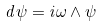<formula> <loc_0><loc_0><loc_500><loc_500>d \psi = i \omega \wedge \psi</formula> 